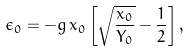<formula> <loc_0><loc_0><loc_500><loc_500>\epsilon _ { 0 } = - g \, x _ { 0 } \left [ \sqrt { \frac { x _ { 0 } } { Y _ { 0 } } } - \frac { 1 } { 2 } \right ] ,</formula> 